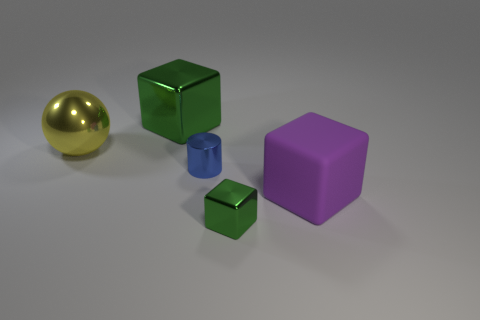Subtract all shiny blocks. How many blocks are left? 1 Add 1 tiny cylinders. How many objects exist? 6 Add 2 green blocks. How many green blocks exist? 4 Subtract 0 red blocks. How many objects are left? 5 Subtract all cylinders. How many objects are left? 4 Subtract all large green shiny things. Subtract all large purple blocks. How many objects are left? 3 Add 2 big purple matte things. How many big purple matte things are left? 3 